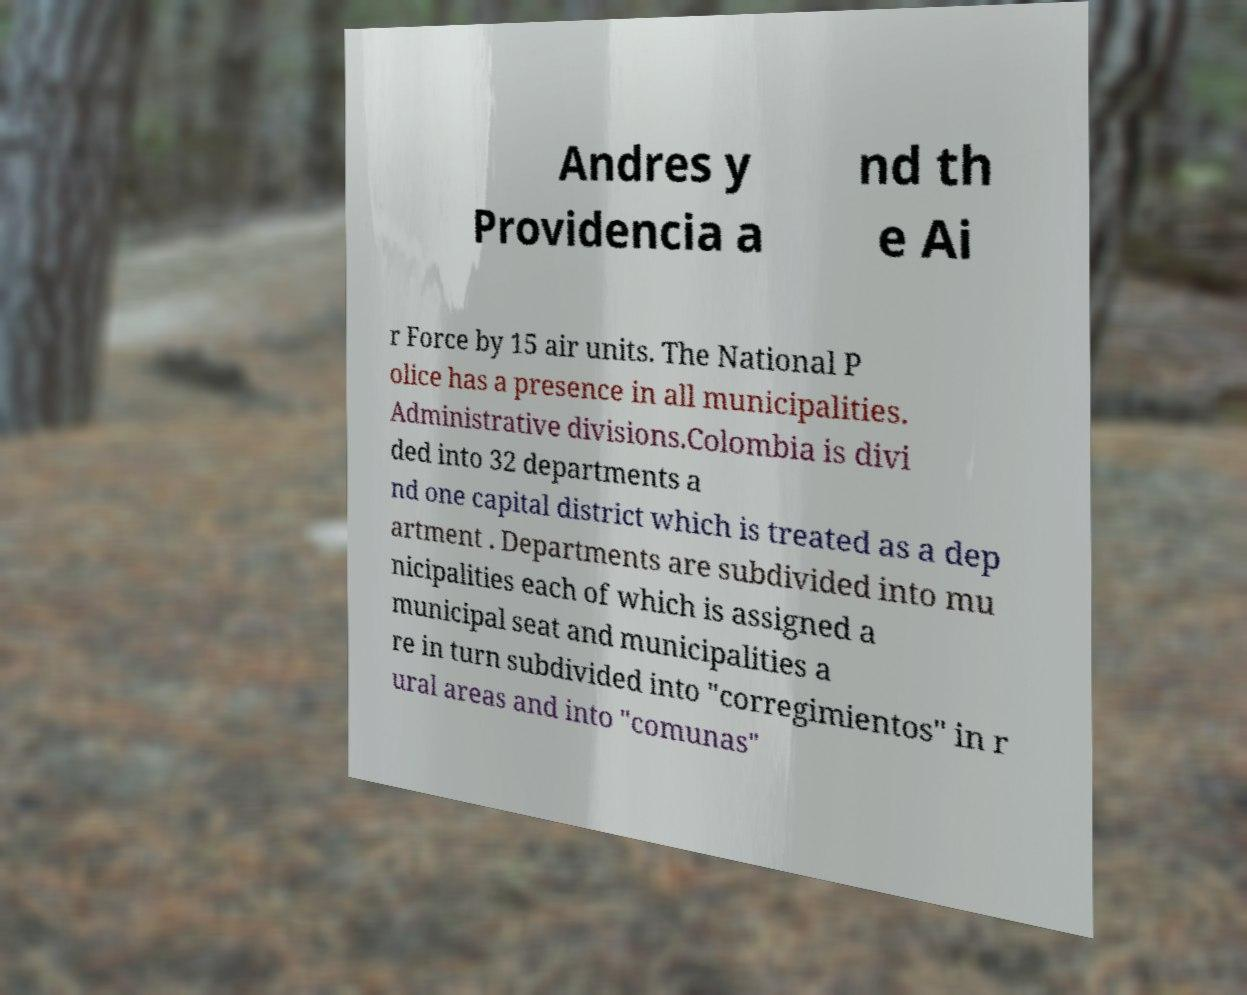Could you extract and type out the text from this image? Andres y Providencia a nd th e Ai r Force by 15 air units. The National P olice has a presence in all municipalities. Administrative divisions.Colombia is divi ded into 32 departments a nd one capital district which is treated as a dep artment . Departments are subdivided into mu nicipalities each of which is assigned a municipal seat and municipalities a re in turn subdivided into "corregimientos" in r ural areas and into "comunas" 